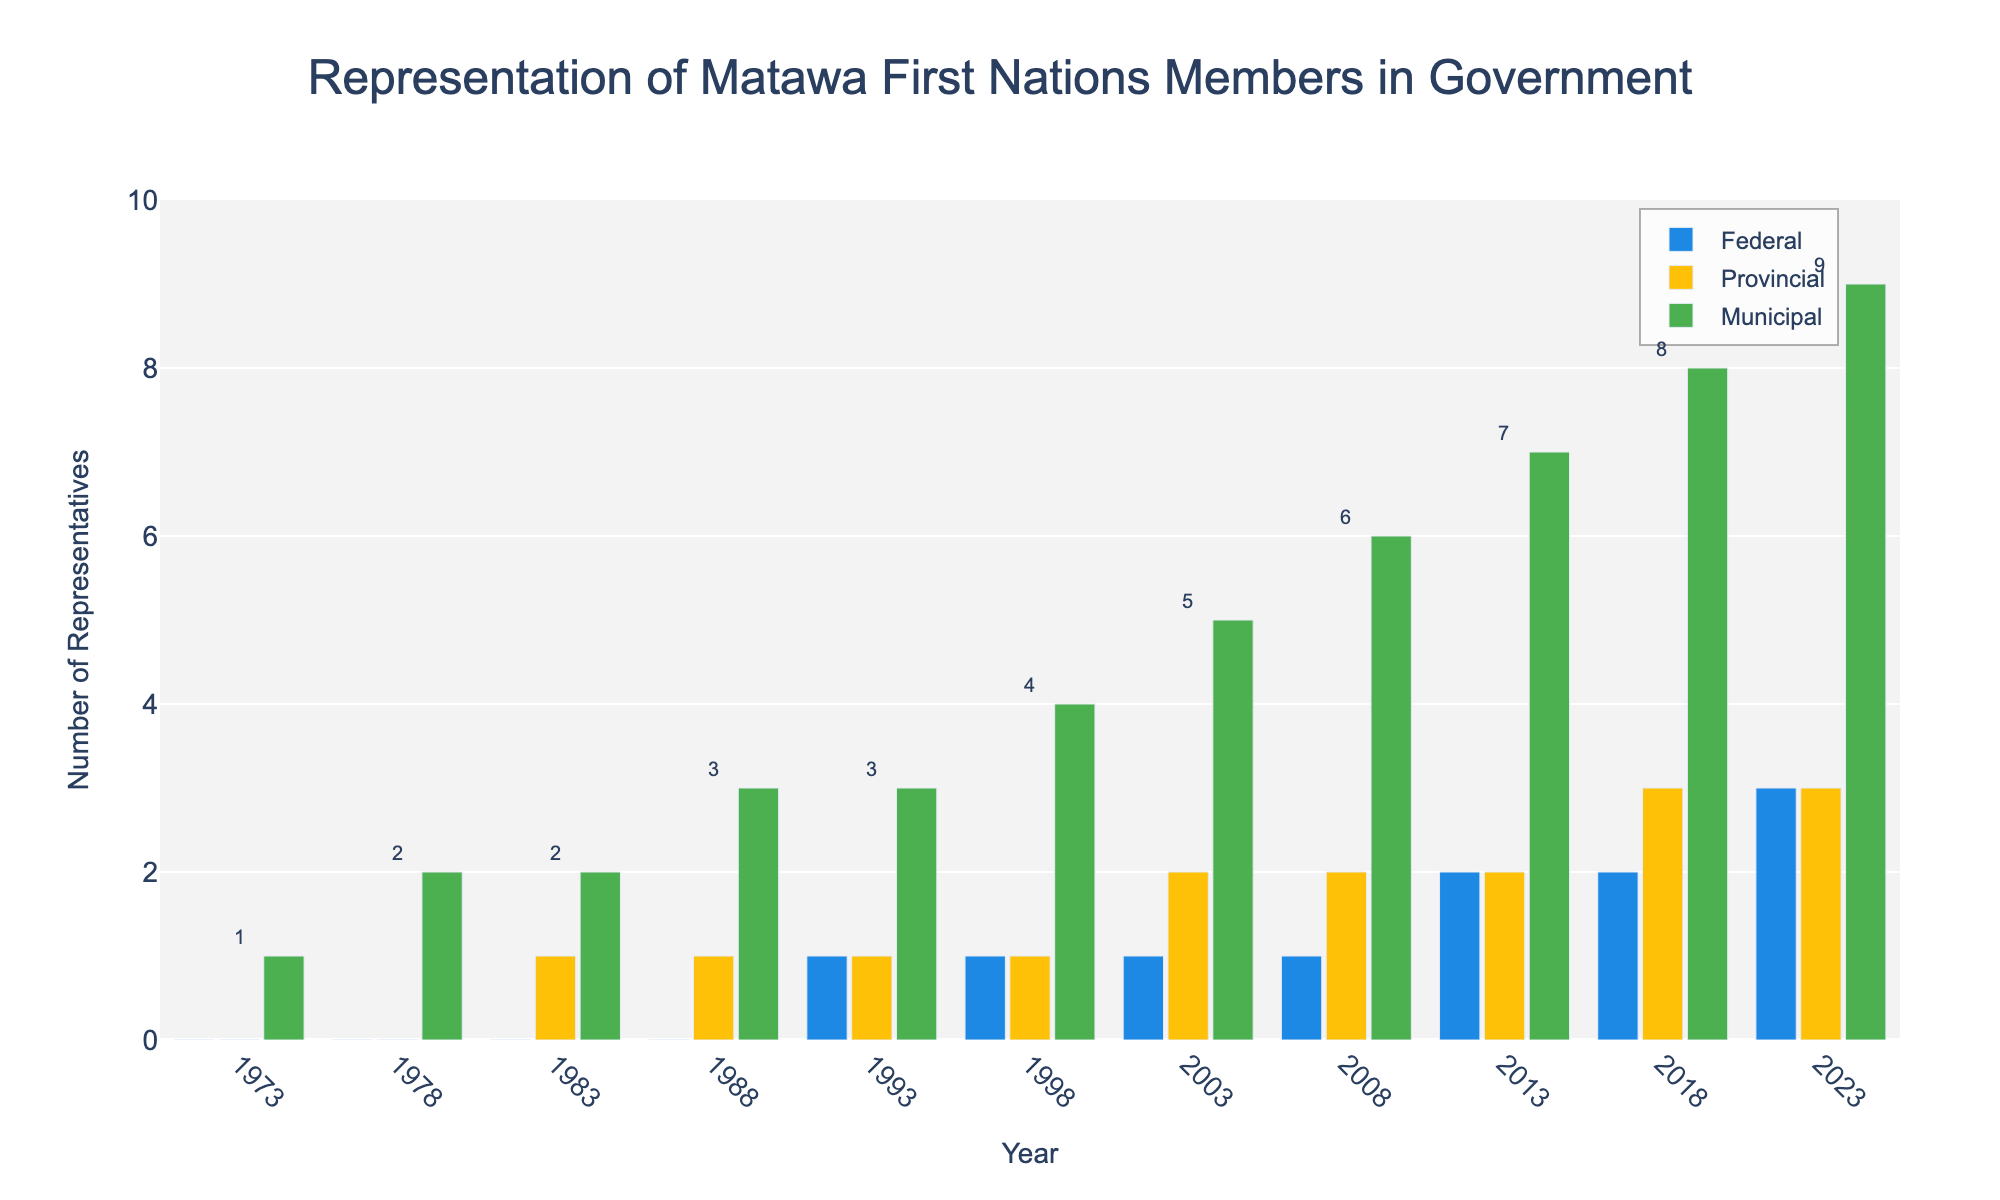Which year first saw representation at all three levels of government? According to the bar chart, we first see non-zero bars for Federal, Provincial, and Municipal levels in 1983. Before that year, either the Federal or Provincial levels had no representatives.
Answer: 1983 Which year had the highest number of Municipal representatives? Looking at the heights of the green bars (Municipal) throughout the years, 2023 has the tallest bar indicating the highest number of Municipal representatives.
Answer: 2023 How did the number of Federal representatives change between 1988 and 1993? In 1988, the number of Federal representatives was 0, and by 1993, it increased to 1. The change is calculated by subtracting 0 from 1.
Answer: Increased by 1 What's the total number of representatives across all government levels in 2003? The bars in 2003 show 1 Federal representative, 2 Provincial representatives, and 5 Municipal representatives. Adding these values gives a total of 1 + 2 + 5 = 8.
Answer: 8 Compare the number of Provincial representatives in 2008 and 2018. Which year had more? In 2008, the number of Provincial representatives was 2. In 2018, it was 3. Comparing these two values, 2018 had more Provincial representatives.
Answer: 2018 What's the average number of Federal representatives from 1993 to 2023? The Federal numbers from 1993 to 2023 are 1, 1, 1, 1, 2, 2, 3. Summing these gives 1+1+1+1+2+2+3 = 11. There are 7 data points, so the average is 11/7 ≈ 1.57.
Answer: 1.57 In which years were there equal numbers of Provincial and Federal representatives? Reviewing the values, the years where Federal equals Provincial are 1993 (1 each), 1998 (1 each), 2003 (1 each), 2008 (2 each), 2013 (2 each), and 2023 (3 each).
Answer: 1993, 1998, 2003, 2008, 2013, 2023 How many times did the number of Municipal representatives increase compared to the previous year? The Municipal numbers increase in 1978, 1983, 1988, 1998, 2003, 2008, 2013, 2018, and 2023 when we compare the numbers to the previous year.
Answer: 9 times If you sum the maximum values of representatives in each level by year, what total do you get? The maximum values for Federal, Provincial, and Municipal are 3, 3, and 9 respectively. Summing these gives 3 + 3 + 9 = 15.
Answer: 15 How has the representation in the Municipal level changed from 1973 to 2023? For Municipal, representation started with 1 in 1973 and increased to 9 in 2023. The change is 9 - 1 = 8.
Answer: Increased by 8 